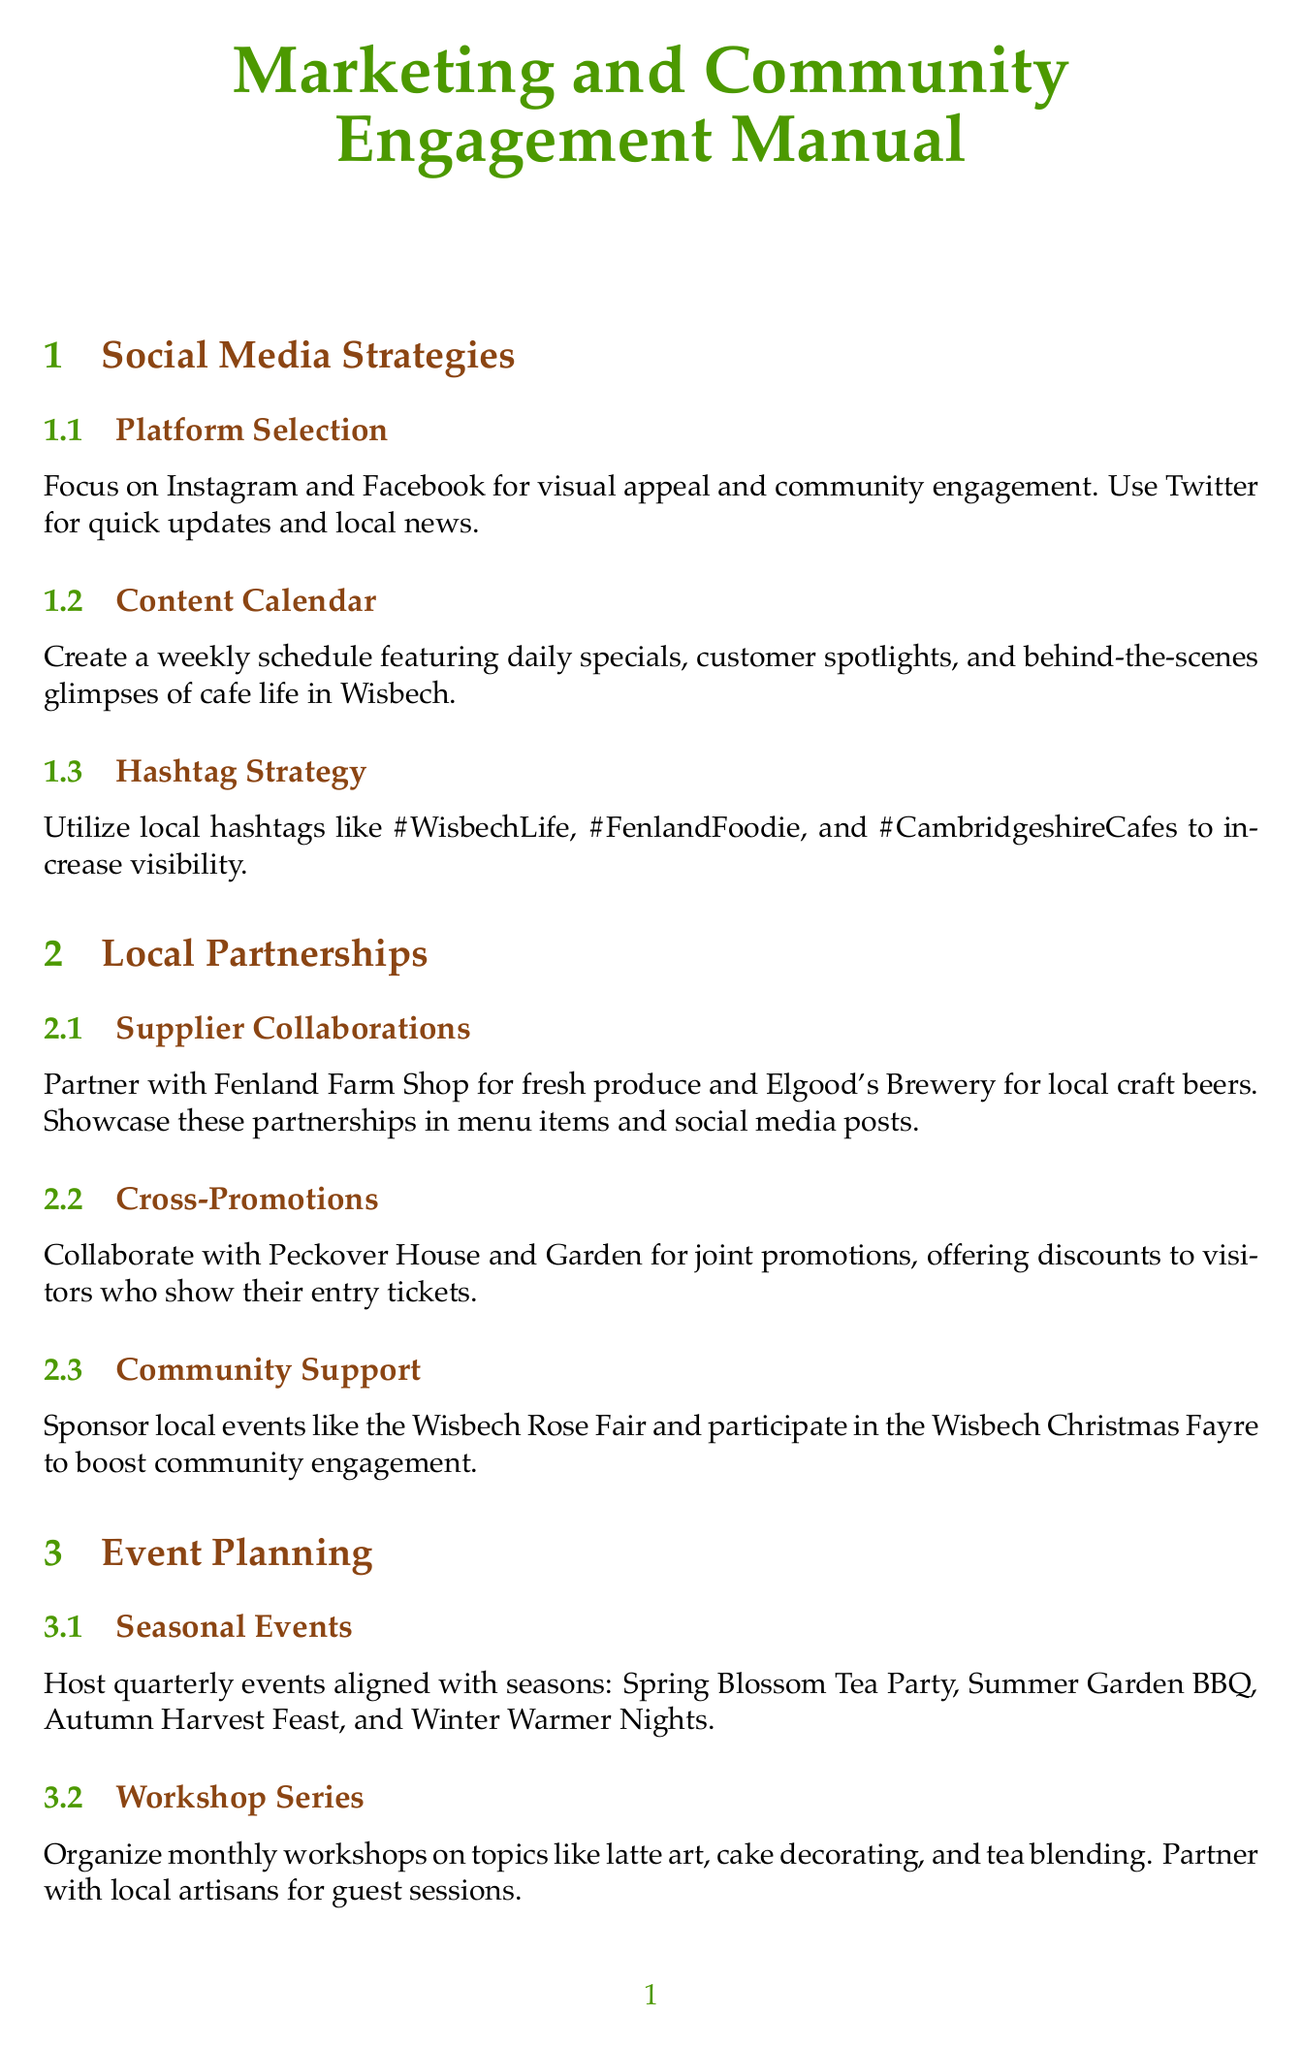what social media platforms should be focused on for marketing? The manual recommends Instagram and Facebook for visual appeal and community engagement.
Answer: Instagram and Facebook what is included in the content calendar? The content calendar should feature daily specials, customer spotlights, and behind-the-scenes glimpses of cafe life.
Answer: Daily specials, customer spotlights, behind-the-scenes which brewery is mentioned for collaboration? The manual suggests partnering with Elgood's Brewery for local craft beers.
Answer: Elgood's Brewery how many tiers are there in the customer loyalty program? The manual states there are Bronze, Silver, and Gold tiers with increasing perks.
Answer: Three what type of events should be held each season? The manual advises hosting Spring Blossom Tea Party, Summer Garden BBQ, Autumn Harvest Feast, and Winter Warmer Nights as seasonal events.
Answer: Seasonal events name one local event the cafe should sponsor to boost community engagement. The document suggests sponsoring the Wisbech Rose Fair to enhance community involvement.
Answer: Wisbech Rose Fair what is a key feature of the digital rewards program? The manual describes a smartphone-based loyalty app offering points for purchases and social media engagement.
Answer: Smartphone-based loyalty app what community gathering series is suggested in the event planning section? The event planning section recommends implementing a 'First Fridays' event series featuring local musicians, artists, and storytellers.
Answer: First Fridays what is the aim of the 'Taste of Wisbech' packages? The manual intends these packages to include cafe vouchers in local tour bundles to encourage tourism.
Answer: Cafe vouchers in local tour bundles 